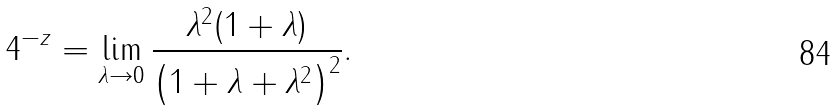<formula> <loc_0><loc_0><loc_500><loc_500>4 ^ { - z } = \lim _ { \lambda \to 0 } \frac { \lambda ^ { 2 } ( 1 + \lambda ) } { \left ( 1 + \lambda + \lambda ^ { 2 } \right ) ^ { 2 } } .</formula> 